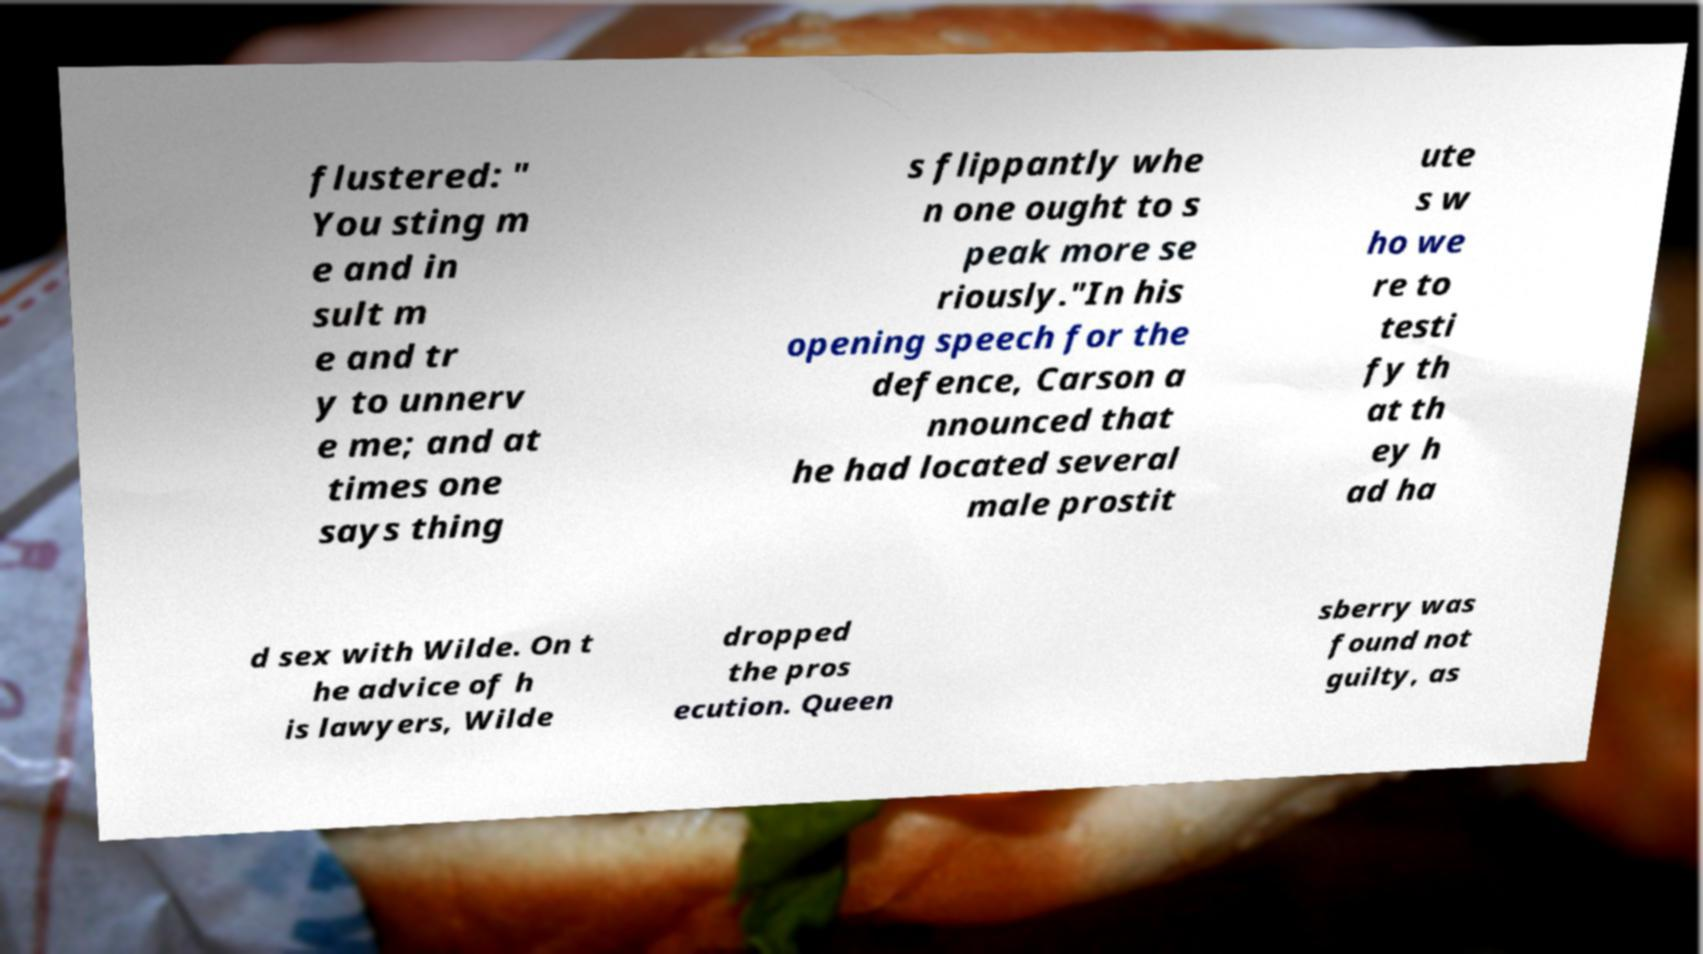Could you extract and type out the text from this image? flustered: " You sting m e and in sult m e and tr y to unnerv e me; and at times one says thing s flippantly whe n one ought to s peak more se riously."In his opening speech for the defence, Carson a nnounced that he had located several male prostit ute s w ho we re to testi fy th at th ey h ad ha d sex with Wilde. On t he advice of h is lawyers, Wilde dropped the pros ecution. Queen sberry was found not guilty, as 